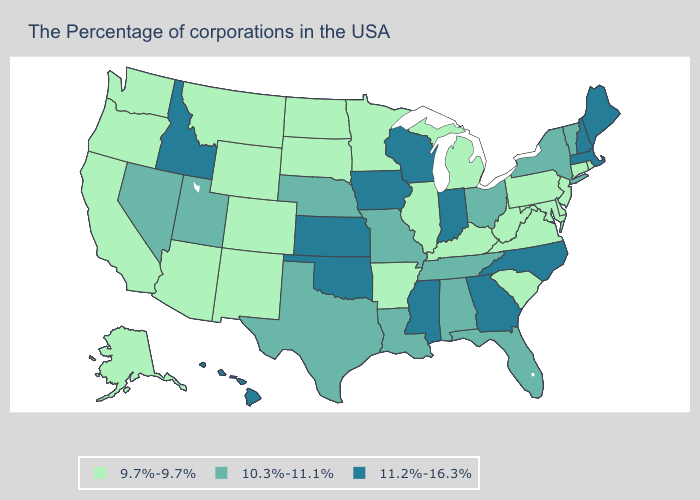Is the legend a continuous bar?
Answer briefly. No. Does Indiana have the same value as Vermont?
Give a very brief answer. No. Among the states that border Minnesota , which have the highest value?
Give a very brief answer. Wisconsin, Iowa. Name the states that have a value in the range 11.2%-16.3%?
Answer briefly. Maine, Massachusetts, New Hampshire, North Carolina, Georgia, Indiana, Wisconsin, Mississippi, Iowa, Kansas, Oklahoma, Idaho, Hawaii. Does the map have missing data?
Concise answer only. No. Which states have the highest value in the USA?
Concise answer only. Maine, Massachusetts, New Hampshire, North Carolina, Georgia, Indiana, Wisconsin, Mississippi, Iowa, Kansas, Oklahoma, Idaho, Hawaii. What is the lowest value in the South?
Answer briefly. 9.7%-9.7%. What is the value of Georgia?
Answer briefly. 11.2%-16.3%. Among the states that border Pennsylvania , which have the lowest value?
Concise answer only. New Jersey, Delaware, Maryland, West Virginia. What is the lowest value in the USA?
Be succinct. 9.7%-9.7%. Which states hav the highest value in the South?
Give a very brief answer. North Carolina, Georgia, Mississippi, Oklahoma. Name the states that have a value in the range 10.3%-11.1%?
Quick response, please. Vermont, New York, Ohio, Florida, Alabama, Tennessee, Louisiana, Missouri, Nebraska, Texas, Utah, Nevada. What is the highest value in the Northeast ?
Quick response, please. 11.2%-16.3%. What is the value of Kentucky?
Write a very short answer. 9.7%-9.7%. 